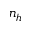Convert formula to latex. <formula><loc_0><loc_0><loc_500><loc_500>n _ { h }</formula> 